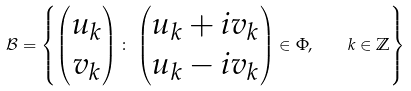Convert formula to latex. <formula><loc_0><loc_0><loc_500><loc_500>\mathcal { B } = \left \{ \begin{pmatrix} u _ { k } \\ v _ { k } \end{pmatrix} \colon \, \begin{pmatrix} u _ { k } + i v _ { k } \\ u _ { k } - i v _ { k } \end{pmatrix} \in \Phi , \quad k \in \mathbb { Z } \right \}</formula> 